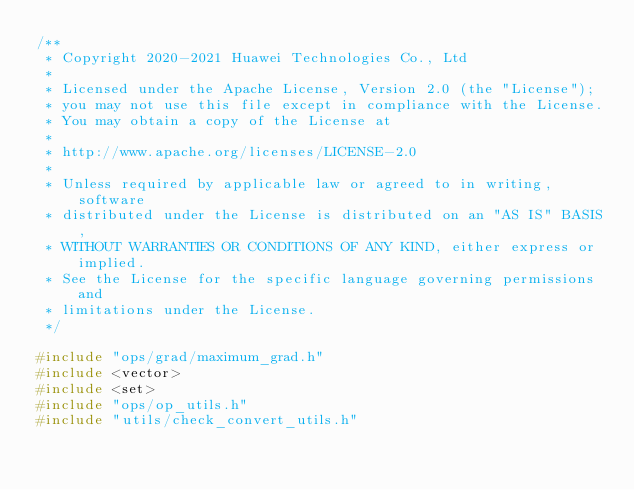<code> <loc_0><loc_0><loc_500><loc_500><_C++_>/**
 * Copyright 2020-2021 Huawei Technologies Co., Ltd
 *
 * Licensed under the Apache License, Version 2.0 (the "License");
 * you may not use this file except in compliance with the License.
 * You may obtain a copy of the License at
 *
 * http://www.apache.org/licenses/LICENSE-2.0
 *
 * Unless required by applicable law or agreed to in writing, software
 * distributed under the License is distributed on an "AS IS" BASIS,
 * WITHOUT WARRANTIES OR CONDITIONS OF ANY KIND, either express or implied.
 * See the License for the specific language governing permissions and
 * limitations under the License.
 */

#include "ops/grad/maximum_grad.h"
#include <vector>
#include <set>
#include "ops/op_utils.h"
#include "utils/check_convert_utils.h"</code> 